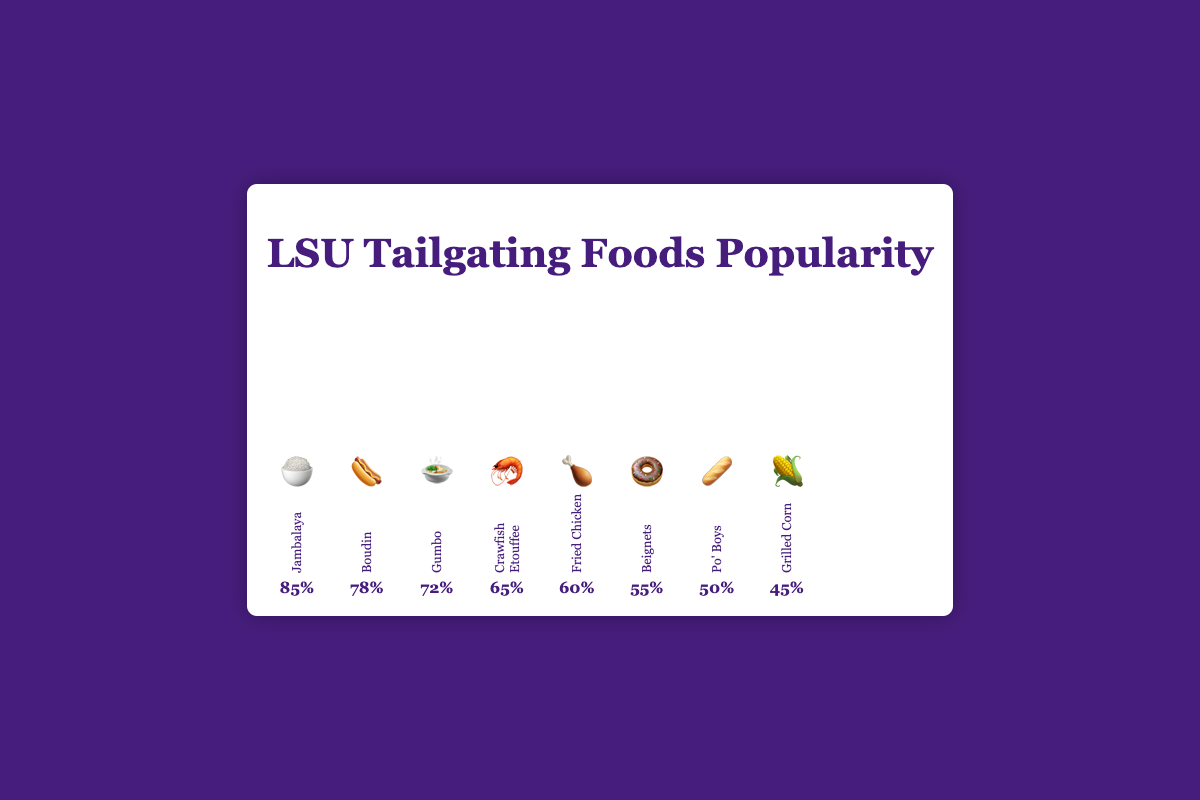Which food has the highest popularity percentage? The food with the highest bar and the highest percentage label is the most popular. Here, Jambalaya has the tallest bar and a label showing 85%.
Answer: Jambalaya Which food is represented by the 🌽 emoji? By looking at the bars, the 🌽 emoji corresponds to the one labelled "Grilled Corn."
Answer: Grilled Corn What is the lowest popularity percentage among the foods? The shortest bar represents the lowest percentage. The bar for Grilled Corn shows a popularity of 45%.
Answer: 45% How much more popular is Jambalaya 🍚 compared to Grilled Corn 🌽? Subtract the popularity percentage of Grilled Corn from that of Jambalaya: 85% - 45% = 40%.
Answer: 40% Which two foods have a popularity difference of exactly 5%? Check the percentage labels for each food and look for a pair where the difference is 5%. Fried Chicken (60%) and Beignets (55%) fit this criterion.
Answer: Fried Chicken and Beignets Rank the top three foods in terms of popularity. Compare the percentages of all foods and select the top three: Jambalaya (85%), Boudin (78%), and Gumbo (72%).
Answer: Jambalaya, Boudin, Gumbo Are there any foods with equal popularity percentages? Observe all the percentage labels and see if any of them are the same. Here, none of the foods share the same percentage.
Answer: No What's the average popularity of Boudin 🌭 and Po' Boys 🥖? Add the popularity percentages of Boudin (78%) and Po' Boys (50%) and divide by 2: (78 + 50) / 2 = 64%.
Answer: 64% Which food is the fourth most popular? Rank the foods by popularity and find the fourth one in the list: Jambalaya (85%), Boudin (78%), Gumbo (72%), Crawfish Etouffee (65%).
Answer: Crawfish Etouffee How much more popular is Gumbo 🍲 compared to Beignets 🍩? Subtract the popularity percentage of Beignets from that of Gumbo: 72% - 55% = 17%.
Answer: 17% Which food has a popularity percentage closest to 60%? Look for the food with a percentage closest to 60%. Fried Chicken matches this exactly with 60%.
Answer: Fried Chicken 